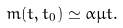<formula> <loc_0><loc_0><loc_500><loc_500>m ( t , t _ { 0 } ) \simeq \alpha \mu t .</formula> 